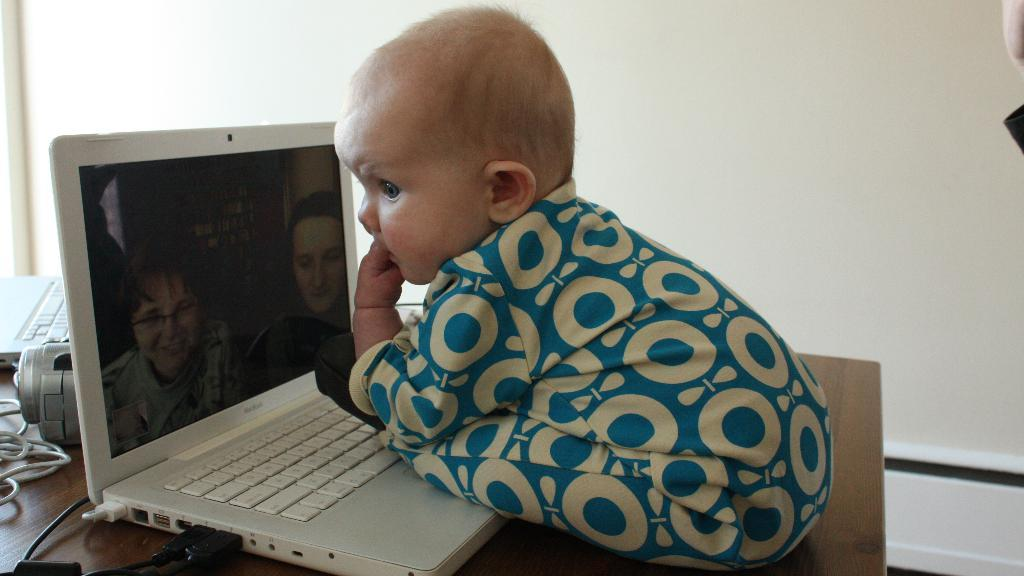What is the main subject of the image? There is a baby in the image. Where is the baby located? The baby is sitting on a table. What is in front of the baby? There is a laptop in front of the baby. What can be seen in the background of the image? There is a wall visible in the background of the image. What type of store can be seen in the background of the image? There is no store visible in the background of the image; it only shows a wall. How does the wind affect the baby in the image? There is no wind present in the image, so it does not affect the baby. 